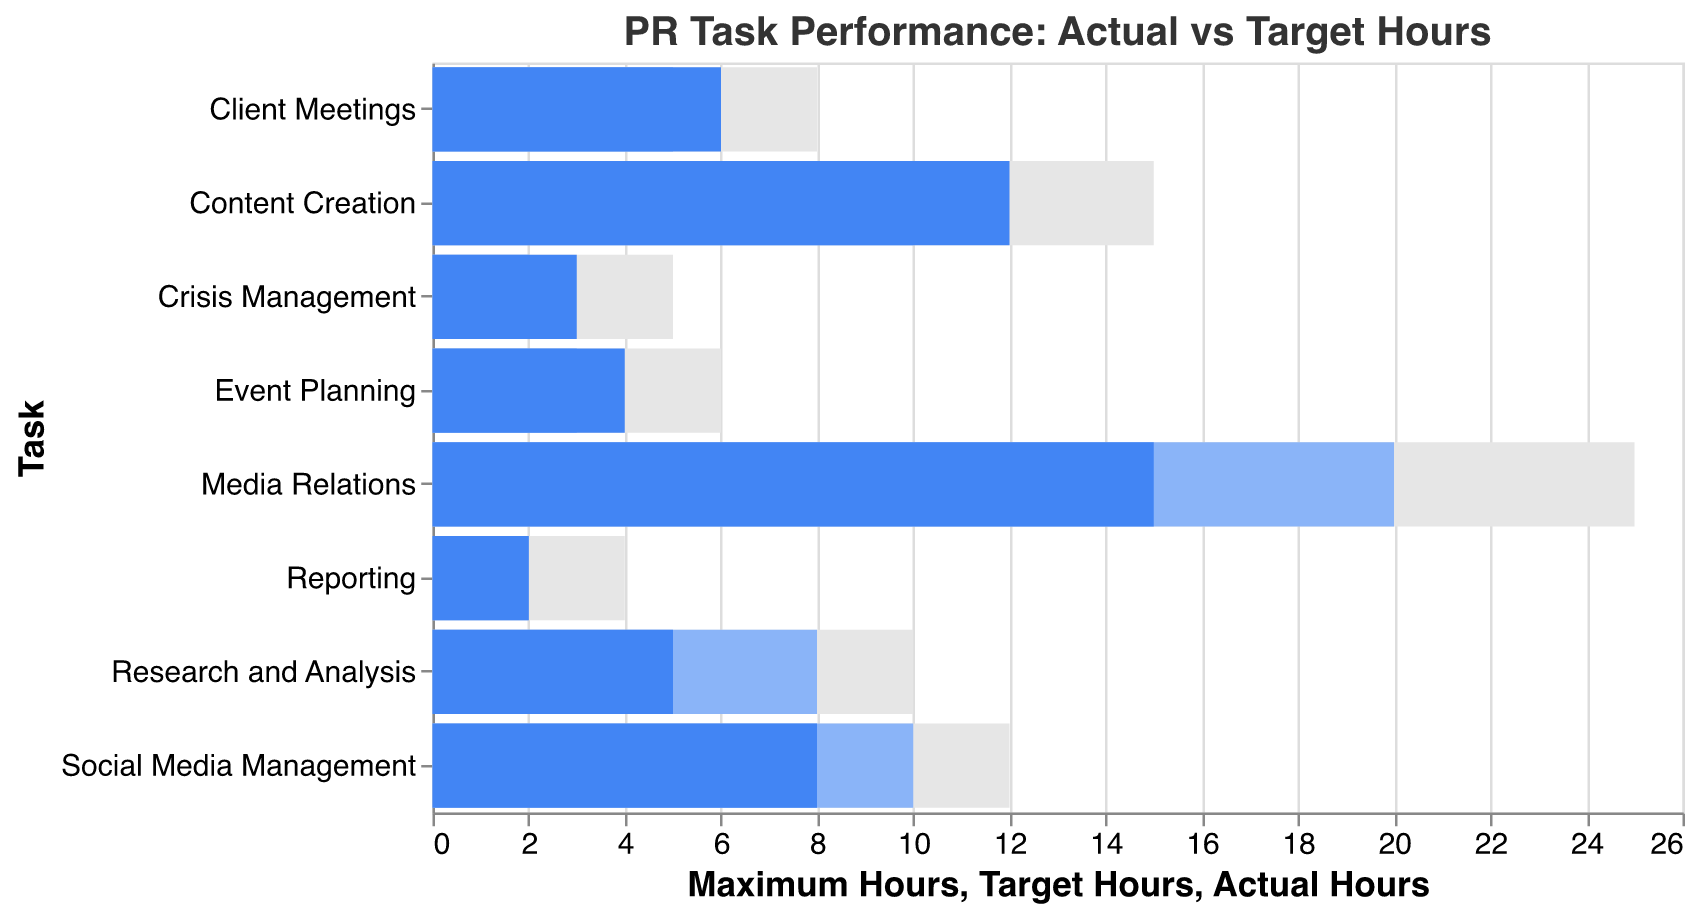What is the title of the chart? The title is displayed at the top of the chart in a larger font size.
Answer: PR Task Performance: Actual vs Target Hours What task has the highest number of actual hours spent? By comparing all the bars representing actual hours, the bar for Media Relations extends the furthest to the right.
Answer: Media Relations How many hours were spent on Social Media Management compared to its target hours? The actual hours for Social Media Management is 8 and the target hours are 10. Therefore, the actual hours are 2 less than the target hours.
Answer: 2 less Which task has the smallest difference between actual and target hours? Comparing the actual and target hours for each task, Reporting has 2 hours for both categories, making the difference 0 hours.
Answer: Reporting What task requires the maximum hours of attention according to the chart? The bar for maximum hours that extends the furthest to the right is for Media Relations, ending at 25 hours.
Answer: Media Relations How many tasks met or exceeded their target hours? Compare each task’s actual hours to its target hours. Media Relations, Content Creation, Client Meetings, and Crisis Management met or exceeded their target hours, so there are 4 tasks.
Answer: 4 tasks What is the total number of target hours for all tasks combined? Sum the target hours for each task: (20 + 10 + 10 + 5 + 8 + 2 + 3 + 2) = 60 hours.
Answer: 60 hours Which task has the highest difference between maximum hours and actual hours? For each task, subtract the actual hours from the maximum hours. Media Relations (25-15=10), Content Creation (15-12=3), Social Media Management (12-8=4), Client Meetings (8-6=2), Research and Analysis (10-5=5), Crisis Management (5-3=2), Event Planning (6-4=2), Reporting (4-2=2). Media Relations has the highest difference of 10 hours.
Answer: Media Relations What is the average number of actual hours spent on all tasks? Sum all actual hours and divide by the number of tasks: (15 + 12 + 8 + 6 + 5 + 3 + 4 + 2)/8 = 55/8 = 6.875 hours.
Answer: 6.875 hours 